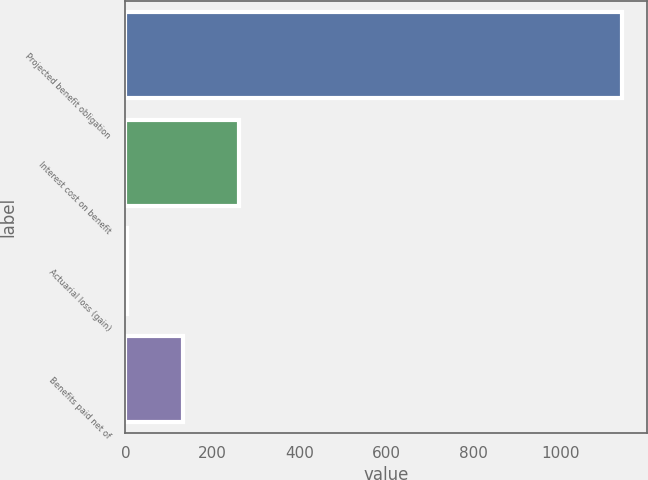<chart> <loc_0><loc_0><loc_500><loc_500><bar_chart><fcel>Projected benefit obligation<fcel>Interest cost on benefit<fcel>Actuarial loss (gain)<fcel>Benefits paid net of<nl><fcel>1141<fcel>260.6<fcel>3<fcel>131.8<nl></chart> 